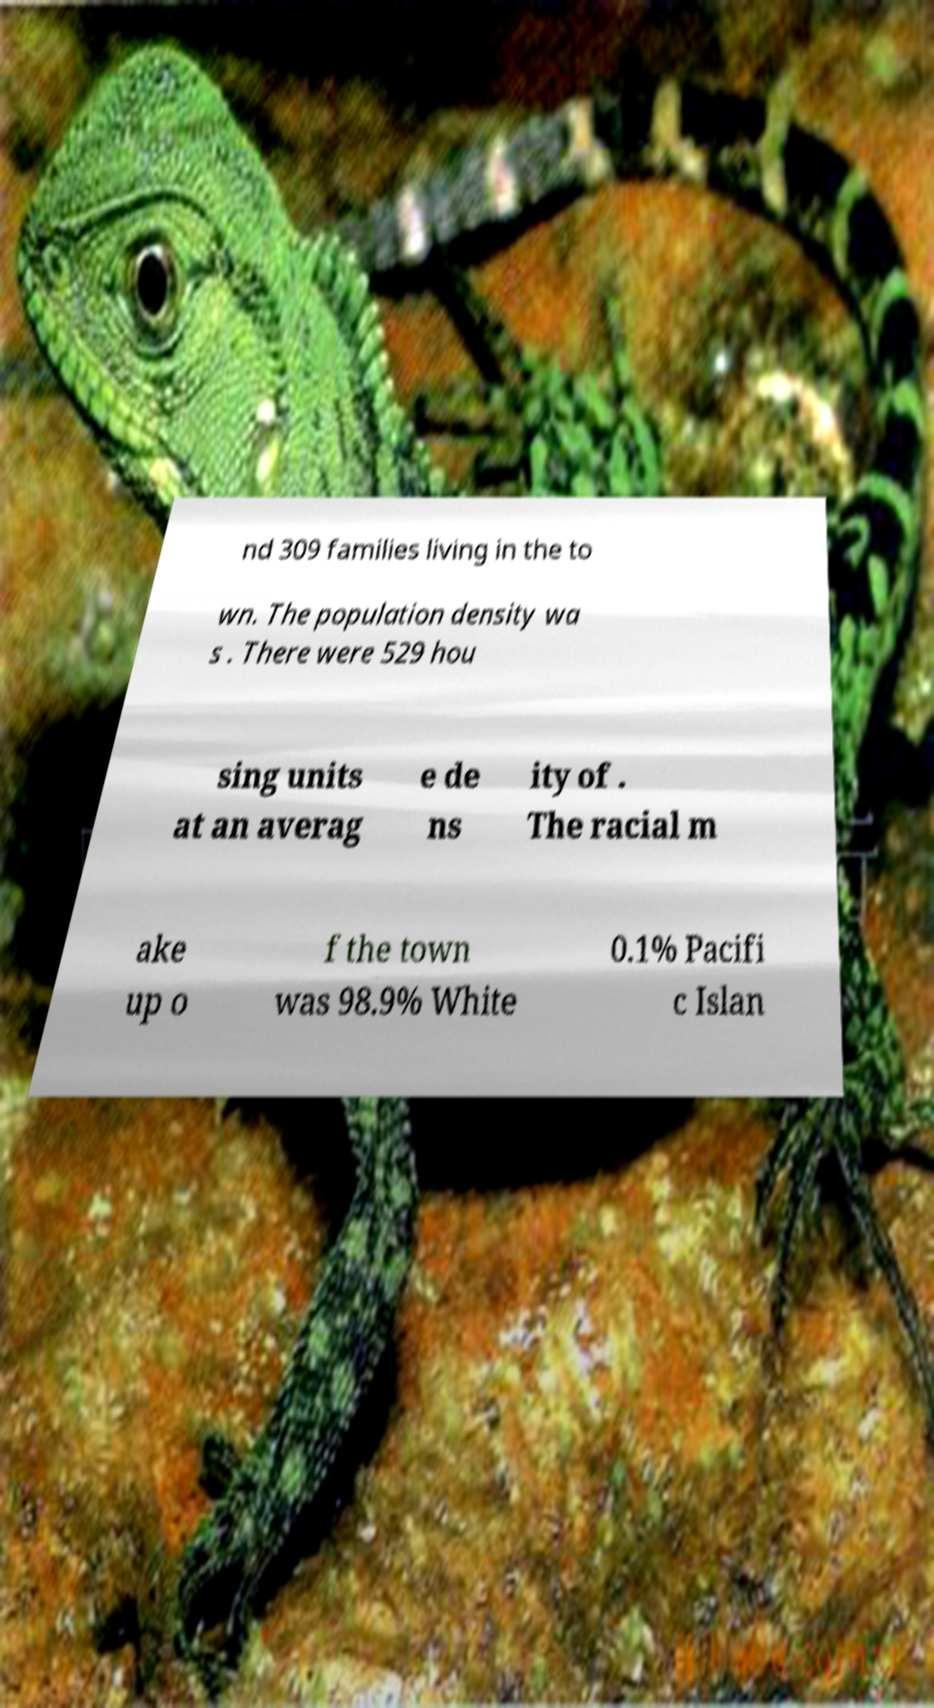Can you accurately transcribe the text from the provided image for me? nd 309 families living in the to wn. The population density wa s . There were 529 hou sing units at an averag e de ns ity of . The racial m ake up o f the town was 98.9% White 0.1% Pacifi c Islan 